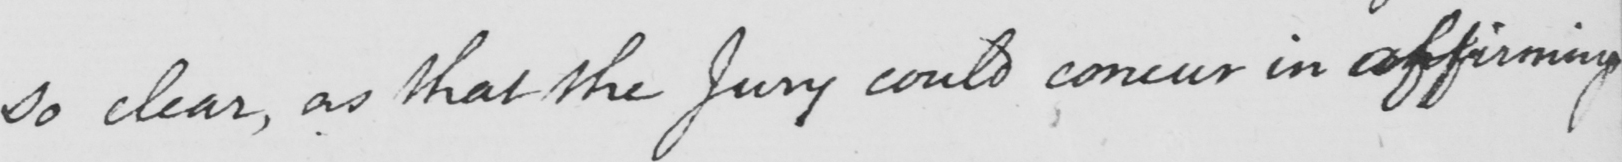What is written in this line of handwriting? so clear, as that the Jury could concur in affirming 